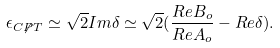<formula> <loc_0><loc_0><loc_500><loc_500>\epsilon _ { C { \not P } T } \simeq \sqrt { 2 } I m \delta \simeq \sqrt { 2 } ( \frac { R e B _ { o } } { R e A _ { o } } - R e \delta ) .</formula> 